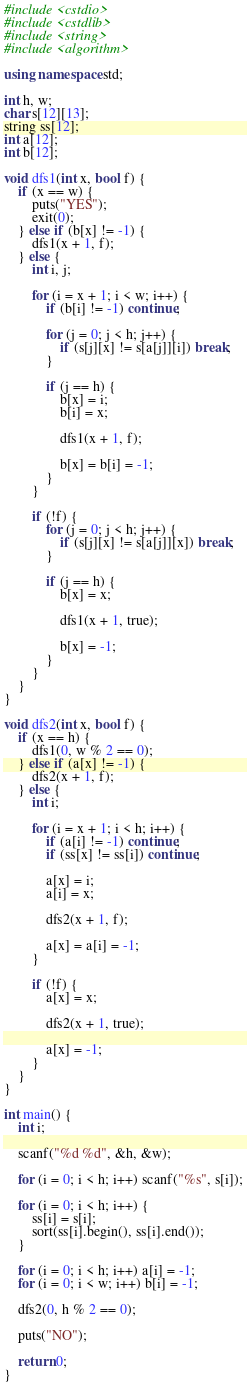<code> <loc_0><loc_0><loc_500><loc_500><_C++_>#include <cstdio>
#include <cstdlib>
#include <string>
#include <algorithm>

using namespace std;

int h, w;
char s[12][13];
string ss[12];
int a[12];
int b[12];

void dfs1(int x, bool f) {
    if (x == w) {
        puts("YES");
        exit(0);
    } else if (b[x] != -1) {
        dfs1(x + 1, f);
    } else {
        int i, j;
        
        for (i = x + 1; i < w; i++) {
            if (b[i] != -1) continue;
            
            for (j = 0; j < h; j++) {
                if (s[j][x] != s[a[j]][i]) break;
            }
            
            if (j == h) {
                b[x] = i;
                b[i] = x;
                
                dfs1(x + 1, f);
                
                b[x] = b[i] = -1;
            }
        }
        
        if (!f) {
            for (j = 0; j < h; j++) {
                if (s[j][x] != s[a[j]][x]) break;
            }
            
            if (j == h) {
                b[x] = x;
                
                dfs1(x + 1, true);
                
                b[x] = -1;
            }
        }
    }
}

void dfs2(int x, bool f) {
    if (x == h) {
        dfs1(0, w % 2 == 0);
    } else if (a[x] != -1) {
        dfs2(x + 1, f);
    } else {
        int i;
        
        for (i = x + 1; i < h; i++) {
            if (a[i] != -1) continue;
            if (ss[x] != ss[i]) continue;
            
            a[x] = i;
            a[i] = x;
            
            dfs2(x + 1, f);
            
            a[x] = a[i] = -1;
        }
        
        if (!f) {
            a[x] = x;
            
            dfs2(x + 1, true);
            
            a[x] = -1;
        }
    }
}

int main() {
    int i;
    
    scanf("%d %d", &h, &w);
    
    for (i = 0; i < h; i++) scanf("%s", s[i]);
    
    for (i = 0; i < h; i++) {
        ss[i] = s[i];
        sort(ss[i].begin(), ss[i].end());
    }
    
    for (i = 0; i < h; i++) a[i] = -1;
    for (i = 0; i < w; i++) b[i] = -1;
    
    dfs2(0, h % 2 == 0);
    
    puts("NO");
    
    return 0;
}
</code> 